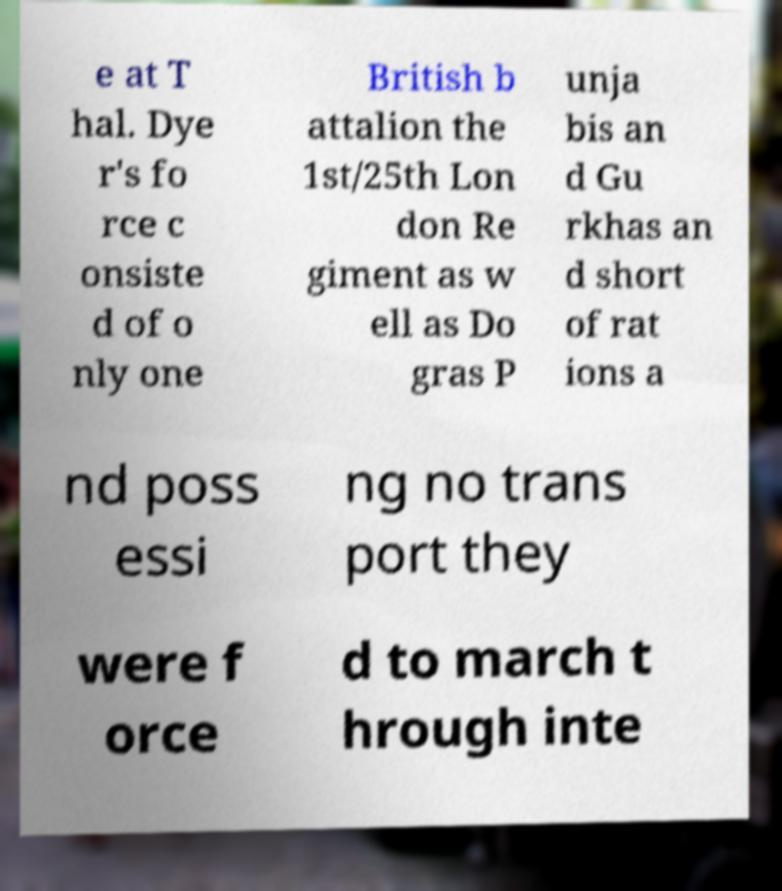Please read and relay the text visible in this image. What does it say? e at T hal. Dye r's fo rce c onsiste d of o nly one British b attalion the 1st/25th Lon don Re giment as w ell as Do gras P unja bis an d Gu rkhas an d short of rat ions a nd poss essi ng no trans port they were f orce d to march t hrough inte 